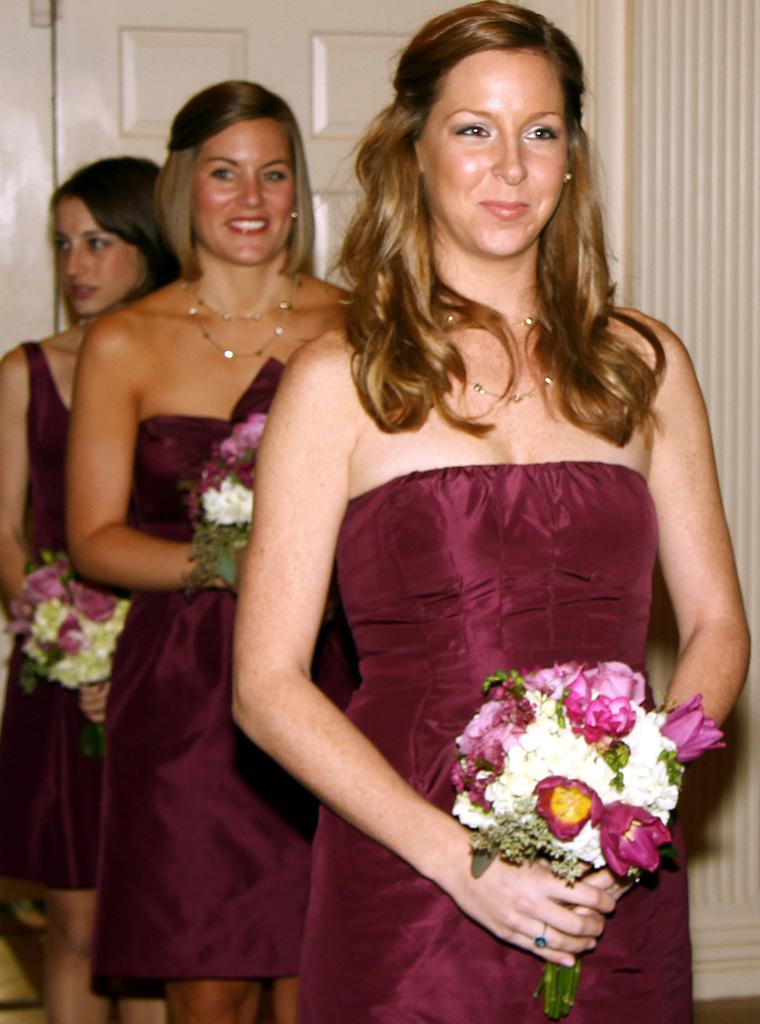What are the ladies in the image doing? The ladies are standing in the center of the image. What are the ladies holding in their hands? The ladies are holding bouquets in their hands. What can be seen in the background of the image? There is a door visible in the background of the image. What type of advertisement can be seen on the desk in the image? There is no desk present in the image, so there cannot be an advertisement on it. 